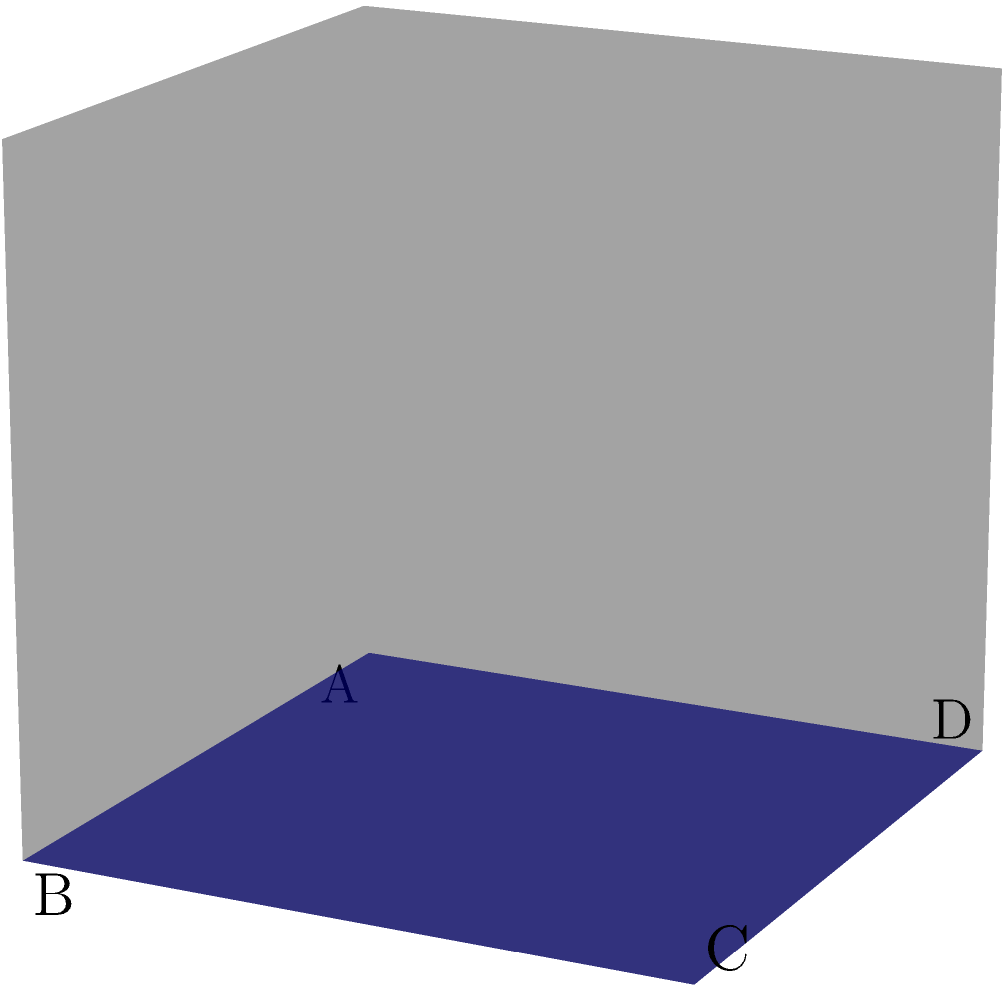As our artistic journey through the fourth dimension unfolds, imagine a hypercube gracefully passing through our three-dimensional canvas. At this moment of cosmic intersection, we witness a cross-section that dances before our eyes like a fleeting masterpiece. If this cross-section were to be captured and framed, what geometric shape would we behold in our gallery of higher-dimensional wonders? Let's deconstruct this multidimensional masterpiece step by step:

1. A hypercube, also known as a tesseract, is a four-dimensional analogue of a cube.

2. As it passes through our three-dimensional space, we can only perceive its three-dimensional cross-sections at any given moment.

3. The cross-section we see depends on the angle and position at which the hypercube intersects our 3D space.

4. In this particular instance, we observe a two-dimensional slice of the hypercube within our three-dimensional canvas.

5. The cross-section forms a closed, flat shape with four vertices (labeled A, B, C, and D in the diagram).

6. These vertices are connected by straight lines, forming four equal sides.

7. The opposite sides of this shape are parallel to each other.

8. All four interior angles of this shape are right angles (90 degrees).

9. This description matches the properties of a square, which is a regular quadrilateral with four equal sides and four right angles.

Therefore, the cross-section of the hypercube at this moment in its journey through our three-dimensional canvas manifests as a square, a perfect embodiment of two-dimensional symmetry within our higher-dimensional exploration.
Answer: Square 